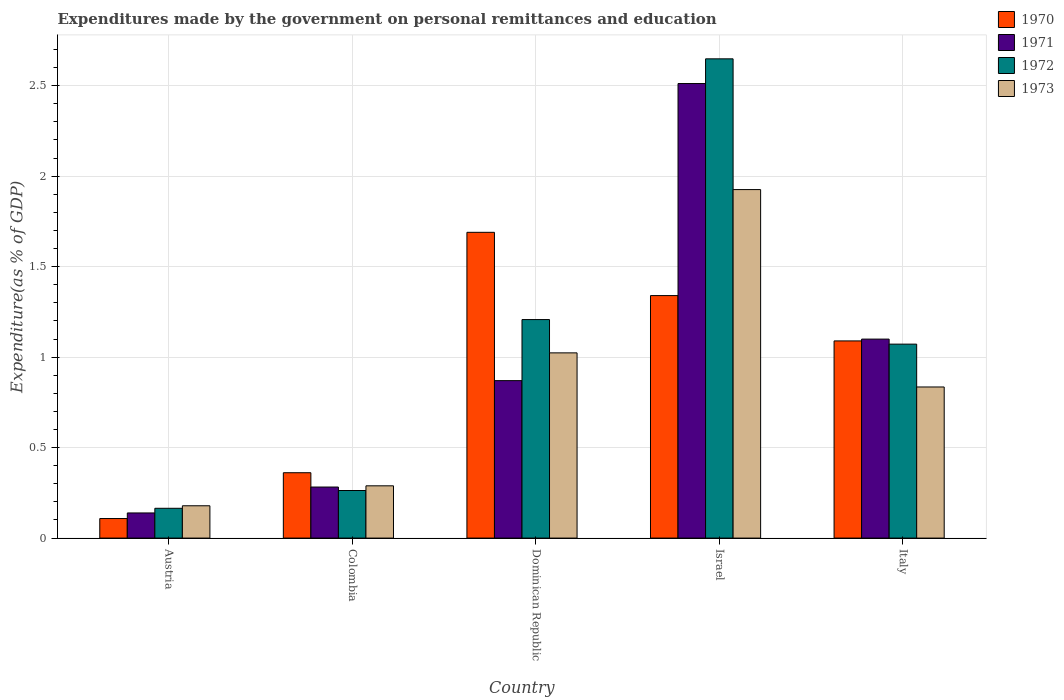How many different coloured bars are there?
Provide a succinct answer. 4. How many groups of bars are there?
Make the answer very short. 5. Are the number of bars per tick equal to the number of legend labels?
Give a very brief answer. Yes. What is the expenditures made by the government on personal remittances and education in 1971 in Dominican Republic?
Offer a very short reply. 0.87. Across all countries, what is the maximum expenditures made by the government on personal remittances and education in 1973?
Your response must be concise. 1.93. Across all countries, what is the minimum expenditures made by the government on personal remittances and education in 1973?
Offer a very short reply. 0.18. In which country was the expenditures made by the government on personal remittances and education in 1972 maximum?
Offer a very short reply. Israel. What is the total expenditures made by the government on personal remittances and education in 1971 in the graph?
Offer a terse response. 4.9. What is the difference between the expenditures made by the government on personal remittances and education in 1970 in Austria and that in Israel?
Provide a succinct answer. -1.23. What is the difference between the expenditures made by the government on personal remittances and education in 1971 in Austria and the expenditures made by the government on personal remittances and education in 1970 in Italy?
Provide a succinct answer. -0.95. What is the average expenditures made by the government on personal remittances and education in 1973 per country?
Offer a terse response. 0.85. What is the difference between the expenditures made by the government on personal remittances and education of/in 1970 and expenditures made by the government on personal remittances and education of/in 1973 in Italy?
Provide a short and direct response. 0.25. What is the ratio of the expenditures made by the government on personal remittances and education in 1970 in Austria to that in Israel?
Ensure brevity in your answer.  0.08. Is the difference between the expenditures made by the government on personal remittances and education in 1970 in Dominican Republic and Italy greater than the difference between the expenditures made by the government on personal remittances and education in 1973 in Dominican Republic and Italy?
Your response must be concise. Yes. What is the difference between the highest and the second highest expenditures made by the government on personal remittances and education in 1973?
Offer a very short reply. -1.09. What is the difference between the highest and the lowest expenditures made by the government on personal remittances and education in 1973?
Give a very brief answer. 1.75. In how many countries, is the expenditures made by the government on personal remittances and education in 1971 greater than the average expenditures made by the government on personal remittances and education in 1971 taken over all countries?
Offer a very short reply. 2. Is the sum of the expenditures made by the government on personal remittances and education in 1971 in Colombia and Israel greater than the maximum expenditures made by the government on personal remittances and education in 1972 across all countries?
Keep it short and to the point. Yes. Is it the case that in every country, the sum of the expenditures made by the government on personal remittances and education in 1972 and expenditures made by the government on personal remittances and education in 1971 is greater than the sum of expenditures made by the government on personal remittances and education in 1973 and expenditures made by the government on personal remittances and education in 1970?
Offer a terse response. No. Is it the case that in every country, the sum of the expenditures made by the government on personal remittances and education in 1971 and expenditures made by the government on personal remittances and education in 1972 is greater than the expenditures made by the government on personal remittances and education in 1970?
Your answer should be compact. Yes. How many bars are there?
Offer a terse response. 20. How many countries are there in the graph?
Ensure brevity in your answer.  5. What is the difference between two consecutive major ticks on the Y-axis?
Offer a terse response. 0.5. Are the values on the major ticks of Y-axis written in scientific E-notation?
Keep it short and to the point. No. Where does the legend appear in the graph?
Offer a terse response. Top right. How many legend labels are there?
Make the answer very short. 4. How are the legend labels stacked?
Your answer should be very brief. Vertical. What is the title of the graph?
Provide a short and direct response. Expenditures made by the government on personal remittances and education. What is the label or title of the Y-axis?
Offer a very short reply. Expenditure(as % of GDP). What is the Expenditure(as % of GDP) of 1970 in Austria?
Your answer should be very brief. 0.11. What is the Expenditure(as % of GDP) of 1971 in Austria?
Ensure brevity in your answer.  0.14. What is the Expenditure(as % of GDP) in 1972 in Austria?
Offer a very short reply. 0.16. What is the Expenditure(as % of GDP) in 1973 in Austria?
Your answer should be compact. 0.18. What is the Expenditure(as % of GDP) of 1970 in Colombia?
Give a very brief answer. 0.36. What is the Expenditure(as % of GDP) in 1971 in Colombia?
Offer a very short reply. 0.28. What is the Expenditure(as % of GDP) of 1972 in Colombia?
Offer a very short reply. 0.26. What is the Expenditure(as % of GDP) of 1973 in Colombia?
Provide a short and direct response. 0.29. What is the Expenditure(as % of GDP) of 1970 in Dominican Republic?
Your answer should be very brief. 1.69. What is the Expenditure(as % of GDP) of 1971 in Dominican Republic?
Your answer should be very brief. 0.87. What is the Expenditure(as % of GDP) in 1972 in Dominican Republic?
Provide a succinct answer. 1.21. What is the Expenditure(as % of GDP) of 1973 in Dominican Republic?
Offer a terse response. 1.02. What is the Expenditure(as % of GDP) in 1970 in Israel?
Make the answer very short. 1.34. What is the Expenditure(as % of GDP) of 1971 in Israel?
Give a very brief answer. 2.51. What is the Expenditure(as % of GDP) of 1972 in Israel?
Keep it short and to the point. 2.65. What is the Expenditure(as % of GDP) in 1973 in Israel?
Give a very brief answer. 1.93. What is the Expenditure(as % of GDP) of 1970 in Italy?
Your answer should be compact. 1.09. What is the Expenditure(as % of GDP) in 1971 in Italy?
Your answer should be compact. 1.1. What is the Expenditure(as % of GDP) in 1972 in Italy?
Your answer should be very brief. 1.07. What is the Expenditure(as % of GDP) of 1973 in Italy?
Give a very brief answer. 0.84. Across all countries, what is the maximum Expenditure(as % of GDP) in 1970?
Offer a very short reply. 1.69. Across all countries, what is the maximum Expenditure(as % of GDP) in 1971?
Offer a very short reply. 2.51. Across all countries, what is the maximum Expenditure(as % of GDP) in 1972?
Make the answer very short. 2.65. Across all countries, what is the maximum Expenditure(as % of GDP) in 1973?
Offer a very short reply. 1.93. Across all countries, what is the minimum Expenditure(as % of GDP) in 1970?
Your answer should be very brief. 0.11. Across all countries, what is the minimum Expenditure(as % of GDP) in 1971?
Your answer should be very brief. 0.14. Across all countries, what is the minimum Expenditure(as % of GDP) in 1972?
Your answer should be compact. 0.16. Across all countries, what is the minimum Expenditure(as % of GDP) in 1973?
Your response must be concise. 0.18. What is the total Expenditure(as % of GDP) in 1970 in the graph?
Ensure brevity in your answer.  4.59. What is the total Expenditure(as % of GDP) in 1971 in the graph?
Provide a short and direct response. 4.9. What is the total Expenditure(as % of GDP) in 1972 in the graph?
Offer a terse response. 5.36. What is the total Expenditure(as % of GDP) of 1973 in the graph?
Your answer should be compact. 4.25. What is the difference between the Expenditure(as % of GDP) of 1970 in Austria and that in Colombia?
Your answer should be compact. -0.25. What is the difference between the Expenditure(as % of GDP) in 1971 in Austria and that in Colombia?
Your answer should be compact. -0.14. What is the difference between the Expenditure(as % of GDP) in 1972 in Austria and that in Colombia?
Offer a terse response. -0.1. What is the difference between the Expenditure(as % of GDP) in 1973 in Austria and that in Colombia?
Provide a short and direct response. -0.11. What is the difference between the Expenditure(as % of GDP) of 1970 in Austria and that in Dominican Republic?
Your response must be concise. -1.58. What is the difference between the Expenditure(as % of GDP) of 1971 in Austria and that in Dominican Republic?
Keep it short and to the point. -0.73. What is the difference between the Expenditure(as % of GDP) in 1972 in Austria and that in Dominican Republic?
Make the answer very short. -1.04. What is the difference between the Expenditure(as % of GDP) of 1973 in Austria and that in Dominican Republic?
Your answer should be very brief. -0.84. What is the difference between the Expenditure(as % of GDP) of 1970 in Austria and that in Israel?
Give a very brief answer. -1.23. What is the difference between the Expenditure(as % of GDP) in 1971 in Austria and that in Israel?
Offer a terse response. -2.37. What is the difference between the Expenditure(as % of GDP) in 1972 in Austria and that in Israel?
Ensure brevity in your answer.  -2.48. What is the difference between the Expenditure(as % of GDP) in 1973 in Austria and that in Israel?
Make the answer very short. -1.75. What is the difference between the Expenditure(as % of GDP) in 1970 in Austria and that in Italy?
Provide a short and direct response. -0.98. What is the difference between the Expenditure(as % of GDP) of 1971 in Austria and that in Italy?
Offer a terse response. -0.96. What is the difference between the Expenditure(as % of GDP) of 1972 in Austria and that in Italy?
Provide a succinct answer. -0.91. What is the difference between the Expenditure(as % of GDP) in 1973 in Austria and that in Italy?
Keep it short and to the point. -0.66. What is the difference between the Expenditure(as % of GDP) of 1970 in Colombia and that in Dominican Republic?
Provide a short and direct response. -1.33. What is the difference between the Expenditure(as % of GDP) of 1971 in Colombia and that in Dominican Republic?
Your response must be concise. -0.59. What is the difference between the Expenditure(as % of GDP) in 1972 in Colombia and that in Dominican Republic?
Provide a succinct answer. -0.94. What is the difference between the Expenditure(as % of GDP) of 1973 in Colombia and that in Dominican Republic?
Provide a short and direct response. -0.73. What is the difference between the Expenditure(as % of GDP) of 1970 in Colombia and that in Israel?
Provide a short and direct response. -0.98. What is the difference between the Expenditure(as % of GDP) of 1971 in Colombia and that in Israel?
Provide a succinct answer. -2.23. What is the difference between the Expenditure(as % of GDP) in 1972 in Colombia and that in Israel?
Your answer should be compact. -2.39. What is the difference between the Expenditure(as % of GDP) in 1973 in Colombia and that in Israel?
Provide a succinct answer. -1.64. What is the difference between the Expenditure(as % of GDP) in 1970 in Colombia and that in Italy?
Your response must be concise. -0.73. What is the difference between the Expenditure(as % of GDP) in 1971 in Colombia and that in Italy?
Provide a succinct answer. -0.82. What is the difference between the Expenditure(as % of GDP) in 1972 in Colombia and that in Italy?
Provide a short and direct response. -0.81. What is the difference between the Expenditure(as % of GDP) in 1973 in Colombia and that in Italy?
Give a very brief answer. -0.55. What is the difference between the Expenditure(as % of GDP) of 1970 in Dominican Republic and that in Israel?
Ensure brevity in your answer.  0.35. What is the difference between the Expenditure(as % of GDP) in 1971 in Dominican Republic and that in Israel?
Your response must be concise. -1.64. What is the difference between the Expenditure(as % of GDP) in 1972 in Dominican Republic and that in Israel?
Keep it short and to the point. -1.44. What is the difference between the Expenditure(as % of GDP) in 1973 in Dominican Republic and that in Israel?
Make the answer very short. -0.9. What is the difference between the Expenditure(as % of GDP) of 1970 in Dominican Republic and that in Italy?
Your answer should be compact. 0.6. What is the difference between the Expenditure(as % of GDP) in 1971 in Dominican Republic and that in Italy?
Make the answer very short. -0.23. What is the difference between the Expenditure(as % of GDP) of 1972 in Dominican Republic and that in Italy?
Your answer should be very brief. 0.14. What is the difference between the Expenditure(as % of GDP) of 1973 in Dominican Republic and that in Italy?
Your response must be concise. 0.19. What is the difference between the Expenditure(as % of GDP) of 1970 in Israel and that in Italy?
Provide a succinct answer. 0.25. What is the difference between the Expenditure(as % of GDP) of 1971 in Israel and that in Italy?
Make the answer very short. 1.41. What is the difference between the Expenditure(as % of GDP) of 1972 in Israel and that in Italy?
Your response must be concise. 1.58. What is the difference between the Expenditure(as % of GDP) in 1970 in Austria and the Expenditure(as % of GDP) in 1971 in Colombia?
Offer a terse response. -0.17. What is the difference between the Expenditure(as % of GDP) of 1970 in Austria and the Expenditure(as % of GDP) of 1972 in Colombia?
Provide a succinct answer. -0.15. What is the difference between the Expenditure(as % of GDP) of 1970 in Austria and the Expenditure(as % of GDP) of 1973 in Colombia?
Provide a short and direct response. -0.18. What is the difference between the Expenditure(as % of GDP) in 1971 in Austria and the Expenditure(as % of GDP) in 1972 in Colombia?
Give a very brief answer. -0.12. What is the difference between the Expenditure(as % of GDP) in 1971 in Austria and the Expenditure(as % of GDP) in 1973 in Colombia?
Your answer should be compact. -0.15. What is the difference between the Expenditure(as % of GDP) of 1972 in Austria and the Expenditure(as % of GDP) of 1973 in Colombia?
Make the answer very short. -0.12. What is the difference between the Expenditure(as % of GDP) of 1970 in Austria and the Expenditure(as % of GDP) of 1971 in Dominican Republic?
Offer a terse response. -0.76. What is the difference between the Expenditure(as % of GDP) of 1970 in Austria and the Expenditure(as % of GDP) of 1972 in Dominican Republic?
Offer a terse response. -1.1. What is the difference between the Expenditure(as % of GDP) of 1970 in Austria and the Expenditure(as % of GDP) of 1973 in Dominican Republic?
Ensure brevity in your answer.  -0.92. What is the difference between the Expenditure(as % of GDP) in 1971 in Austria and the Expenditure(as % of GDP) in 1972 in Dominican Republic?
Your answer should be compact. -1.07. What is the difference between the Expenditure(as % of GDP) of 1971 in Austria and the Expenditure(as % of GDP) of 1973 in Dominican Republic?
Your answer should be very brief. -0.88. What is the difference between the Expenditure(as % of GDP) in 1972 in Austria and the Expenditure(as % of GDP) in 1973 in Dominican Republic?
Provide a short and direct response. -0.86. What is the difference between the Expenditure(as % of GDP) in 1970 in Austria and the Expenditure(as % of GDP) in 1971 in Israel?
Make the answer very short. -2.4. What is the difference between the Expenditure(as % of GDP) of 1970 in Austria and the Expenditure(as % of GDP) of 1972 in Israel?
Make the answer very short. -2.54. What is the difference between the Expenditure(as % of GDP) in 1970 in Austria and the Expenditure(as % of GDP) in 1973 in Israel?
Offer a very short reply. -1.82. What is the difference between the Expenditure(as % of GDP) in 1971 in Austria and the Expenditure(as % of GDP) in 1972 in Israel?
Make the answer very short. -2.51. What is the difference between the Expenditure(as % of GDP) in 1971 in Austria and the Expenditure(as % of GDP) in 1973 in Israel?
Your answer should be compact. -1.79. What is the difference between the Expenditure(as % of GDP) of 1972 in Austria and the Expenditure(as % of GDP) of 1973 in Israel?
Your response must be concise. -1.76. What is the difference between the Expenditure(as % of GDP) of 1970 in Austria and the Expenditure(as % of GDP) of 1971 in Italy?
Provide a succinct answer. -0.99. What is the difference between the Expenditure(as % of GDP) of 1970 in Austria and the Expenditure(as % of GDP) of 1972 in Italy?
Make the answer very short. -0.96. What is the difference between the Expenditure(as % of GDP) in 1970 in Austria and the Expenditure(as % of GDP) in 1973 in Italy?
Provide a short and direct response. -0.73. What is the difference between the Expenditure(as % of GDP) in 1971 in Austria and the Expenditure(as % of GDP) in 1972 in Italy?
Provide a short and direct response. -0.93. What is the difference between the Expenditure(as % of GDP) in 1971 in Austria and the Expenditure(as % of GDP) in 1973 in Italy?
Provide a succinct answer. -0.7. What is the difference between the Expenditure(as % of GDP) of 1972 in Austria and the Expenditure(as % of GDP) of 1973 in Italy?
Your answer should be compact. -0.67. What is the difference between the Expenditure(as % of GDP) of 1970 in Colombia and the Expenditure(as % of GDP) of 1971 in Dominican Republic?
Offer a terse response. -0.51. What is the difference between the Expenditure(as % of GDP) of 1970 in Colombia and the Expenditure(as % of GDP) of 1972 in Dominican Republic?
Keep it short and to the point. -0.85. What is the difference between the Expenditure(as % of GDP) of 1970 in Colombia and the Expenditure(as % of GDP) of 1973 in Dominican Republic?
Provide a succinct answer. -0.66. What is the difference between the Expenditure(as % of GDP) of 1971 in Colombia and the Expenditure(as % of GDP) of 1972 in Dominican Republic?
Provide a succinct answer. -0.93. What is the difference between the Expenditure(as % of GDP) in 1971 in Colombia and the Expenditure(as % of GDP) in 1973 in Dominican Republic?
Offer a very short reply. -0.74. What is the difference between the Expenditure(as % of GDP) in 1972 in Colombia and the Expenditure(as % of GDP) in 1973 in Dominican Republic?
Keep it short and to the point. -0.76. What is the difference between the Expenditure(as % of GDP) in 1970 in Colombia and the Expenditure(as % of GDP) in 1971 in Israel?
Give a very brief answer. -2.15. What is the difference between the Expenditure(as % of GDP) in 1970 in Colombia and the Expenditure(as % of GDP) in 1972 in Israel?
Offer a terse response. -2.29. What is the difference between the Expenditure(as % of GDP) in 1970 in Colombia and the Expenditure(as % of GDP) in 1973 in Israel?
Make the answer very short. -1.56. What is the difference between the Expenditure(as % of GDP) of 1971 in Colombia and the Expenditure(as % of GDP) of 1972 in Israel?
Keep it short and to the point. -2.37. What is the difference between the Expenditure(as % of GDP) in 1971 in Colombia and the Expenditure(as % of GDP) in 1973 in Israel?
Ensure brevity in your answer.  -1.64. What is the difference between the Expenditure(as % of GDP) in 1972 in Colombia and the Expenditure(as % of GDP) in 1973 in Israel?
Offer a terse response. -1.66. What is the difference between the Expenditure(as % of GDP) of 1970 in Colombia and the Expenditure(as % of GDP) of 1971 in Italy?
Make the answer very short. -0.74. What is the difference between the Expenditure(as % of GDP) in 1970 in Colombia and the Expenditure(as % of GDP) in 1972 in Italy?
Ensure brevity in your answer.  -0.71. What is the difference between the Expenditure(as % of GDP) in 1970 in Colombia and the Expenditure(as % of GDP) in 1973 in Italy?
Your answer should be compact. -0.47. What is the difference between the Expenditure(as % of GDP) of 1971 in Colombia and the Expenditure(as % of GDP) of 1972 in Italy?
Your response must be concise. -0.79. What is the difference between the Expenditure(as % of GDP) of 1971 in Colombia and the Expenditure(as % of GDP) of 1973 in Italy?
Ensure brevity in your answer.  -0.55. What is the difference between the Expenditure(as % of GDP) in 1972 in Colombia and the Expenditure(as % of GDP) in 1973 in Italy?
Ensure brevity in your answer.  -0.57. What is the difference between the Expenditure(as % of GDP) of 1970 in Dominican Republic and the Expenditure(as % of GDP) of 1971 in Israel?
Offer a terse response. -0.82. What is the difference between the Expenditure(as % of GDP) in 1970 in Dominican Republic and the Expenditure(as % of GDP) in 1972 in Israel?
Your answer should be compact. -0.96. What is the difference between the Expenditure(as % of GDP) in 1970 in Dominican Republic and the Expenditure(as % of GDP) in 1973 in Israel?
Keep it short and to the point. -0.24. What is the difference between the Expenditure(as % of GDP) of 1971 in Dominican Republic and the Expenditure(as % of GDP) of 1972 in Israel?
Keep it short and to the point. -1.78. What is the difference between the Expenditure(as % of GDP) in 1971 in Dominican Republic and the Expenditure(as % of GDP) in 1973 in Israel?
Ensure brevity in your answer.  -1.06. What is the difference between the Expenditure(as % of GDP) of 1972 in Dominican Republic and the Expenditure(as % of GDP) of 1973 in Israel?
Make the answer very short. -0.72. What is the difference between the Expenditure(as % of GDP) in 1970 in Dominican Republic and the Expenditure(as % of GDP) in 1971 in Italy?
Your response must be concise. 0.59. What is the difference between the Expenditure(as % of GDP) of 1970 in Dominican Republic and the Expenditure(as % of GDP) of 1972 in Italy?
Provide a short and direct response. 0.62. What is the difference between the Expenditure(as % of GDP) of 1970 in Dominican Republic and the Expenditure(as % of GDP) of 1973 in Italy?
Your answer should be very brief. 0.85. What is the difference between the Expenditure(as % of GDP) in 1971 in Dominican Republic and the Expenditure(as % of GDP) in 1972 in Italy?
Your answer should be compact. -0.2. What is the difference between the Expenditure(as % of GDP) of 1971 in Dominican Republic and the Expenditure(as % of GDP) of 1973 in Italy?
Keep it short and to the point. 0.04. What is the difference between the Expenditure(as % of GDP) of 1972 in Dominican Republic and the Expenditure(as % of GDP) of 1973 in Italy?
Offer a very short reply. 0.37. What is the difference between the Expenditure(as % of GDP) of 1970 in Israel and the Expenditure(as % of GDP) of 1971 in Italy?
Your answer should be very brief. 0.24. What is the difference between the Expenditure(as % of GDP) in 1970 in Israel and the Expenditure(as % of GDP) in 1972 in Italy?
Offer a very short reply. 0.27. What is the difference between the Expenditure(as % of GDP) in 1970 in Israel and the Expenditure(as % of GDP) in 1973 in Italy?
Offer a terse response. 0.51. What is the difference between the Expenditure(as % of GDP) in 1971 in Israel and the Expenditure(as % of GDP) in 1972 in Italy?
Your answer should be compact. 1.44. What is the difference between the Expenditure(as % of GDP) in 1971 in Israel and the Expenditure(as % of GDP) in 1973 in Italy?
Keep it short and to the point. 1.68. What is the difference between the Expenditure(as % of GDP) of 1972 in Israel and the Expenditure(as % of GDP) of 1973 in Italy?
Keep it short and to the point. 1.81. What is the average Expenditure(as % of GDP) of 1970 per country?
Give a very brief answer. 0.92. What is the average Expenditure(as % of GDP) in 1971 per country?
Give a very brief answer. 0.98. What is the average Expenditure(as % of GDP) of 1972 per country?
Your answer should be compact. 1.07. What is the average Expenditure(as % of GDP) of 1973 per country?
Offer a terse response. 0.85. What is the difference between the Expenditure(as % of GDP) in 1970 and Expenditure(as % of GDP) in 1971 in Austria?
Your answer should be compact. -0.03. What is the difference between the Expenditure(as % of GDP) of 1970 and Expenditure(as % of GDP) of 1972 in Austria?
Offer a terse response. -0.06. What is the difference between the Expenditure(as % of GDP) in 1970 and Expenditure(as % of GDP) in 1973 in Austria?
Ensure brevity in your answer.  -0.07. What is the difference between the Expenditure(as % of GDP) of 1971 and Expenditure(as % of GDP) of 1972 in Austria?
Keep it short and to the point. -0.03. What is the difference between the Expenditure(as % of GDP) in 1971 and Expenditure(as % of GDP) in 1973 in Austria?
Your answer should be very brief. -0.04. What is the difference between the Expenditure(as % of GDP) in 1972 and Expenditure(as % of GDP) in 1973 in Austria?
Give a very brief answer. -0.01. What is the difference between the Expenditure(as % of GDP) of 1970 and Expenditure(as % of GDP) of 1971 in Colombia?
Ensure brevity in your answer.  0.08. What is the difference between the Expenditure(as % of GDP) of 1970 and Expenditure(as % of GDP) of 1972 in Colombia?
Your response must be concise. 0.1. What is the difference between the Expenditure(as % of GDP) in 1970 and Expenditure(as % of GDP) in 1973 in Colombia?
Offer a very short reply. 0.07. What is the difference between the Expenditure(as % of GDP) of 1971 and Expenditure(as % of GDP) of 1972 in Colombia?
Provide a short and direct response. 0.02. What is the difference between the Expenditure(as % of GDP) in 1971 and Expenditure(as % of GDP) in 1973 in Colombia?
Your answer should be compact. -0.01. What is the difference between the Expenditure(as % of GDP) in 1972 and Expenditure(as % of GDP) in 1973 in Colombia?
Provide a succinct answer. -0.03. What is the difference between the Expenditure(as % of GDP) of 1970 and Expenditure(as % of GDP) of 1971 in Dominican Republic?
Give a very brief answer. 0.82. What is the difference between the Expenditure(as % of GDP) of 1970 and Expenditure(as % of GDP) of 1972 in Dominican Republic?
Make the answer very short. 0.48. What is the difference between the Expenditure(as % of GDP) of 1970 and Expenditure(as % of GDP) of 1973 in Dominican Republic?
Your answer should be very brief. 0.67. What is the difference between the Expenditure(as % of GDP) in 1971 and Expenditure(as % of GDP) in 1972 in Dominican Republic?
Your answer should be compact. -0.34. What is the difference between the Expenditure(as % of GDP) in 1971 and Expenditure(as % of GDP) in 1973 in Dominican Republic?
Make the answer very short. -0.15. What is the difference between the Expenditure(as % of GDP) of 1972 and Expenditure(as % of GDP) of 1973 in Dominican Republic?
Provide a short and direct response. 0.18. What is the difference between the Expenditure(as % of GDP) in 1970 and Expenditure(as % of GDP) in 1971 in Israel?
Give a very brief answer. -1.17. What is the difference between the Expenditure(as % of GDP) of 1970 and Expenditure(as % of GDP) of 1972 in Israel?
Keep it short and to the point. -1.31. What is the difference between the Expenditure(as % of GDP) in 1970 and Expenditure(as % of GDP) in 1973 in Israel?
Ensure brevity in your answer.  -0.59. What is the difference between the Expenditure(as % of GDP) of 1971 and Expenditure(as % of GDP) of 1972 in Israel?
Your answer should be very brief. -0.14. What is the difference between the Expenditure(as % of GDP) in 1971 and Expenditure(as % of GDP) in 1973 in Israel?
Your response must be concise. 0.59. What is the difference between the Expenditure(as % of GDP) of 1972 and Expenditure(as % of GDP) of 1973 in Israel?
Your answer should be compact. 0.72. What is the difference between the Expenditure(as % of GDP) of 1970 and Expenditure(as % of GDP) of 1971 in Italy?
Your response must be concise. -0.01. What is the difference between the Expenditure(as % of GDP) in 1970 and Expenditure(as % of GDP) in 1972 in Italy?
Provide a short and direct response. 0.02. What is the difference between the Expenditure(as % of GDP) in 1970 and Expenditure(as % of GDP) in 1973 in Italy?
Offer a terse response. 0.25. What is the difference between the Expenditure(as % of GDP) in 1971 and Expenditure(as % of GDP) in 1972 in Italy?
Your answer should be compact. 0.03. What is the difference between the Expenditure(as % of GDP) of 1971 and Expenditure(as % of GDP) of 1973 in Italy?
Keep it short and to the point. 0.26. What is the difference between the Expenditure(as % of GDP) of 1972 and Expenditure(as % of GDP) of 1973 in Italy?
Your answer should be very brief. 0.24. What is the ratio of the Expenditure(as % of GDP) of 1970 in Austria to that in Colombia?
Ensure brevity in your answer.  0.3. What is the ratio of the Expenditure(as % of GDP) of 1971 in Austria to that in Colombia?
Your answer should be compact. 0.49. What is the ratio of the Expenditure(as % of GDP) of 1972 in Austria to that in Colombia?
Provide a short and direct response. 0.63. What is the ratio of the Expenditure(as % of GDP) of 1973 in Austria to that in Colombia?
Offer a very short reply. 0.62. What is the ratio of the Expenditure(as % of GDP) in 1970 in Austria to that in Dominican Republic?
Keep it short and to the point. 0.06. What is the ratio of the Expenditure(as % of GDP) of 1971 in Austria to that in Dominican Republic?
Ensure brevity in your answer.  0.16. What is the ratio of the Expenditure(as % of GDP) of 1972 in Austria to that in Dominican Republic?
Your response must be concise. 0.14. What is the ratio of the Expenditure(as % of GDP) of 1973 in Austria to that in Dominican Republic?
Ensure brevity in your answer.  0.17. What is the ratio of the Expenditure(as % of GDP) of 1970 in Austria to that in Israel?
Make the answer very short. 0.08. What is the ratio of the Expenditure(as % of GDP) of 1971 in Austria to that in Israel?
Keep it short and to the point. 0.06. What is the ratio of the Expenditure(as % of GDP) of 1972 in Austria to that in Israel?
Offer a terse response. 0.06. What is the ratio of the Expenditure(as % of GDP) in 1973 in Austria to that in Israel?
Your answer should be very brief. 0.09. What is the ratio of the Expenditure(as % of GDP) of 1970 in Austria to that in Italy?
Make the answer very short. 0.1. What is the ratio of the Expenditure(as % of GDP) in 1971 in Austria to that in Italy?
Your answer should be compact. 0.13. What is the ratio of the Expenditure(as % of GDP) in 1972 in Austria to that in Italy?
Ensure brevity in your answer.  0.15. What is the ratio of the Expenditure(as % of GDP) in 1973 in Austria to that in Italy?
Offer a terse response. 0.21. What is the ratio of the Expenditure(as % of GDP) in 1970 in Colombia to that in Dominican Republic?
Your answer should be very brief. 0.21. What is the ratio of the Expenditure(as % of GDP) in 1971 in Colombia to that in Dominican Republic?
Make the answer very short. 0.32. What is the ratio of the Expenditure(as % of GDP) in 1972 in Colombia to that in Dominican Republic?
Give a very brief answer. 0.22. What is the ratio of the Expenditure(as % of GDP) in 1973 in Colombia to that in Dominican Republic?
Offer a terse response. 0.28. What is the ratio of the Expenditure(as % of GDP) in 1970 in Colombia to that in Israel?
Offer a very short reply. 0.27. What is the ratio of the Expenditure(as % of GDP) in 1971 in Colombia to that in Israel?
Ensure brevity in your answer.  0.11. What is the ratio of the Expenditure(as % of GDP) in 1972 in Colombia to that in Israel?
Make the answer very short. 0.1. What is the ratio of the Expenditure(as % of GDP) of 1973 in Colombia to that in Israel?
Your answer should be very brief. 0.15. What is the ratio of the Expenditure(as % of GDP) of 1970 in Colombia to that in Italy?
Make the answer very short. 0.33. What is the ratio of the Expenditure(as % of GDP) in 1971 in Colombia to that in Italy?
Ensure brevity in your answer.  0.26. What is the ratio of the Expenditure(as % of GDP) in 1972 in Colombia to that in Italy?
Your answer should be very brief. 0.25. What is the ratio of the Expenditure(as % of GDP) of 1973 in Colombia to that in Italy?
Keep it short and to the point. 0.35. What is the ratio of the Expenditure(as % of GDP) of 1970 in Dominican Republic to that in Israel?
Make the answer very short. 1.26. What is the ratio of the Expenditure(as % of GDP) of 1971 in Dominican Republic to that in Israel?
Offer a very short reply. 0.35. What is the ratio of the Expenditure(as % of GDP) of 1972 in Dominican Republic to that in Israel?
Offer a very short reply. 0.46. What is the ratio of the Expenditure(as % of GDP) of 1973 in Dominican Republic to that in Israel?
Offer a terse response. 0.53. What is the ratio of the Expenditure(as % of GDP) of 1970 in Dominican Republic to that in Italy?
Your response must be concise. 1.55. What is the ratio of the Expenditure(as % of GDP) of 1971 in Dominican Republic to that in Italy?
Your answer should be very brief. 0.79. What is the ratio of the Expenditure(as % of GDP) of 1972 in Dominican Republic to that in Italy?
Your response must be concise. 1.13. What is the ratio of the Expenditure(as % of GDP) in 1973 in Dominican Republic to that in Italy?
Your answer should be very brief. 1.23. What is the ratio of the Expenditure(as % of GDP) of 1970 in Israel to that in Italy?
Your response must be concise. 1.23. What is the ratio of the Expenditure(as % of GDP) in 1971 in Israel to that in Italy?
Ensure brevity in your answer.  2.28. What is the ratio of the Expenditure(as % of GDP) of 1972 in Israel to that in Italy?
Make the answer very short. 2.47. What is the ratio of the Expenditure(as % of GDP) in 1973 in Israel to that in Italy?
Keep it short and to the point. 2.31. What is the difference between the highest and the second highest Expenditure(as % of GDP) in 1970?
Offer a very short reply. 0.35. What is the difference between the highest and the second highest Expenditure(as % of GDP) in 1971?
Ensure brevity in your answer.  1.41. What is the difference between the highest and the second highest Expenditure(as % of GDP) in 1972?
Keep it short and to the point. 1.44. What is the difference between the highest and the second highest Expenditure(as % of GDP) of 1973?
Your answer should be compact. 0.9. What is the difference between the highest and the lowest Expenditure(as % of GDP) in 1970?
Give a very brief answer. 1.58. What is the difference between the highest and the lowest Expenditure(as % of GDP) in 1971?
Your response must be concise. 2.37. What is the difference between the highest and the lowest Expenditure(as % of GDP) of 1972?
Offer a terse response. 2.48. What is the difference between the highest and the lowest Expenditure(as % of GDP) in 1973?
Offer a very short reply. 1.75. 